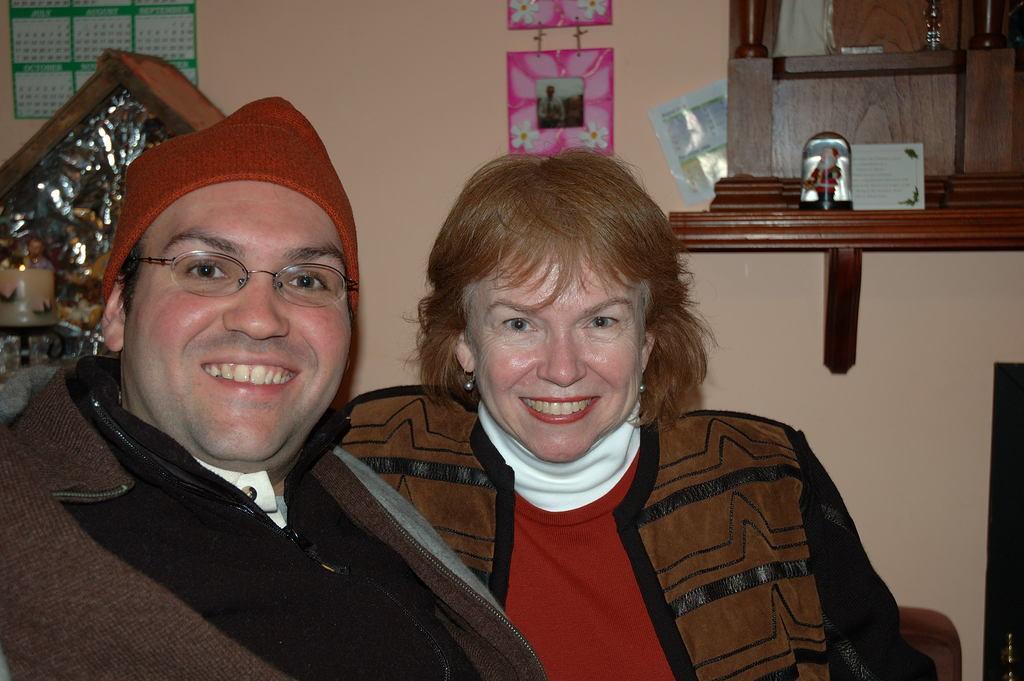Describe this image in one or two sentences. As we can see in the image there is a wall, photo frame and two people sitting over here. 